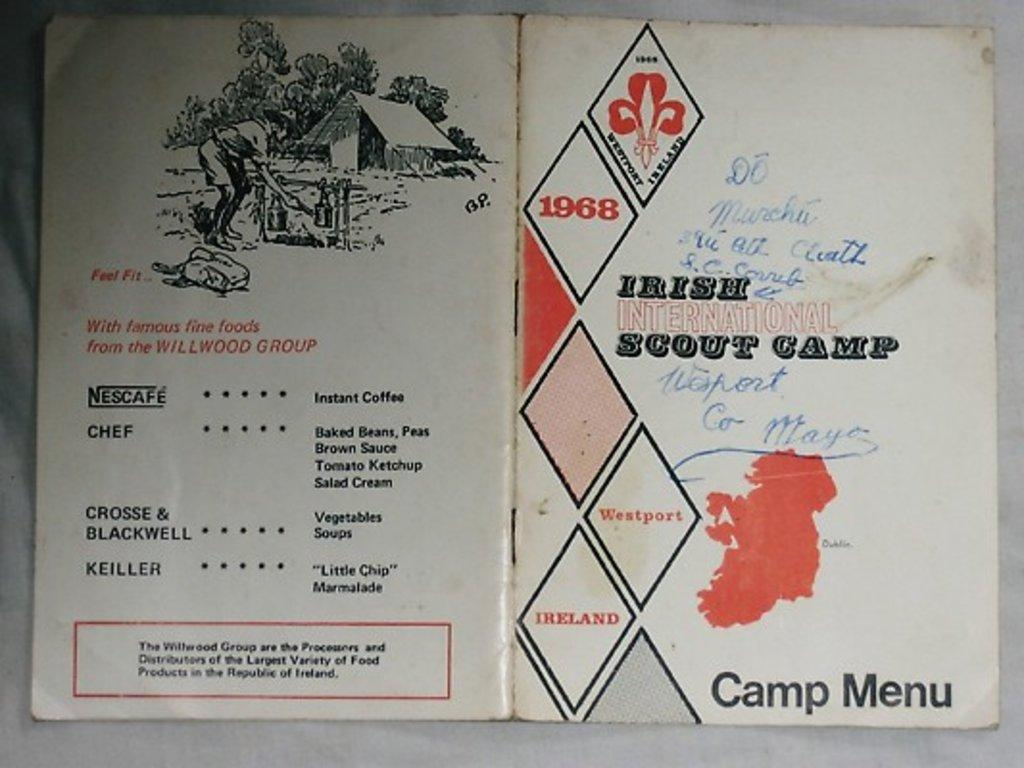Provide a one-sentence caption for the provided image. A menu for the Irish International Scout Camp for 1968. 